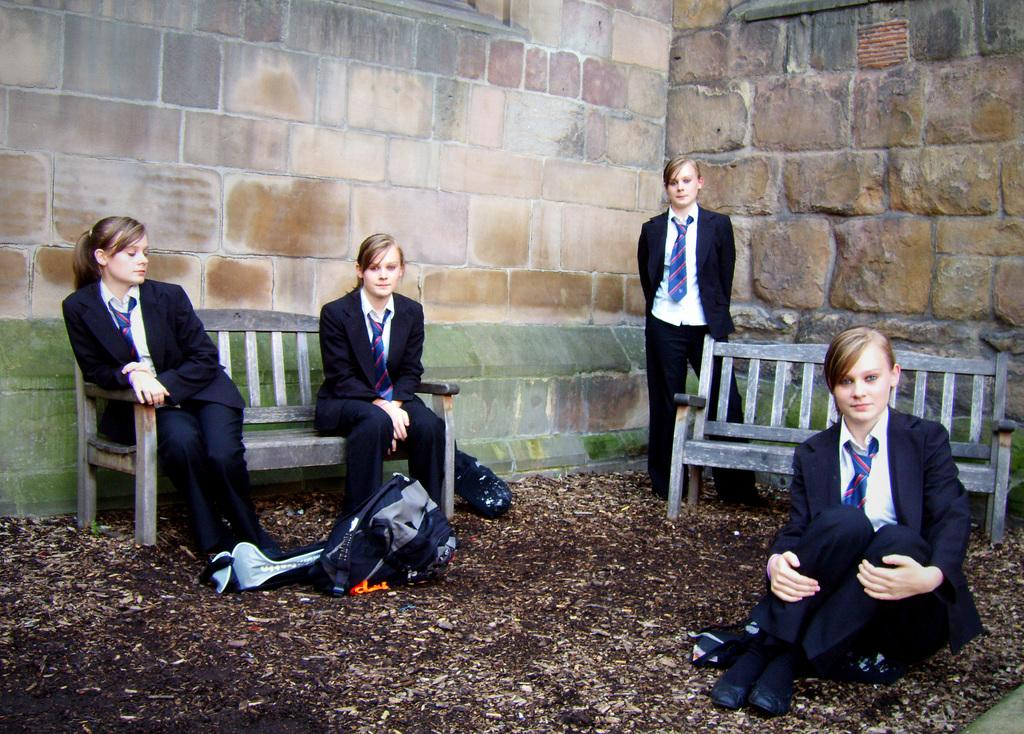What is the main subject of the image? The main subject of the image is a group of women. How are the women positioned in the image? Two women are sitting on a bench, and one woman is standing. What is on the ground near the women? There is a bag on the ground. What can be seen in the background of the image? There is a wall visible in the image. What type of wire is being used by the women to communicate in the image? There is no wire present in the image, and the women are not using any communication devices. Can you see a boat in the image? No, there is no boat present in the image. 